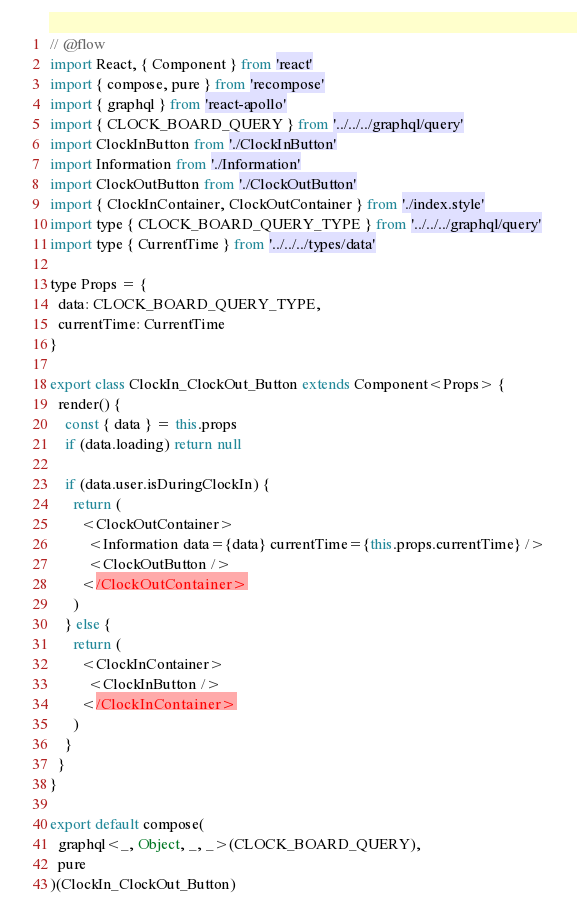Convert code to text. <code><loc_0><loc_0><loc_500><loc_500><_JavaScript_>// @flow
import React, { Component } from 'react'
import { compose, pure } from 'recompose'
import { graphql } from 'react-apollo'
import { CLOCK_BOARD_QUERY } from '../../../graphql/query'
import ClockInButton from './ClockInButton'
import Information from './Information'
import ClockOutButton from './ClockOutButton'
import { ClockInContainer, ClockOutContainer } from './index.style'
import type { CLOCK_BOARD_QUERY_TYPE } from '../../../graphql/query'
import type { CurrentTime } from '../../../types/data'

type Props = {
  data: CLOCK_BOARD_QUERY_TYPE,
  currentTime: CurrentTime
}

export class ClockIn_ClockOut_Button extends Component<Props> {
  render() {
    const { data } = this.props
    if (data.loading) return null

    if (data.user.isDuringClockIn) {
      return (
        <ClockOutContainer>
          <Information data={data} currentTime={this.props.currentTime} />
          <ClockOutButton />
        </ClockOutContainer>
      )
    } else {
      return (
        <ClockInContainer>
          <ClockInButton />
        </ClockInContainer>
      )
    }
  }
}

export default compose(
  graphql<_, Object, _, _>(CLOCK_BOARD_QUERY),
  pure
)(ClockIn_ClockOut_Button)
</code> 